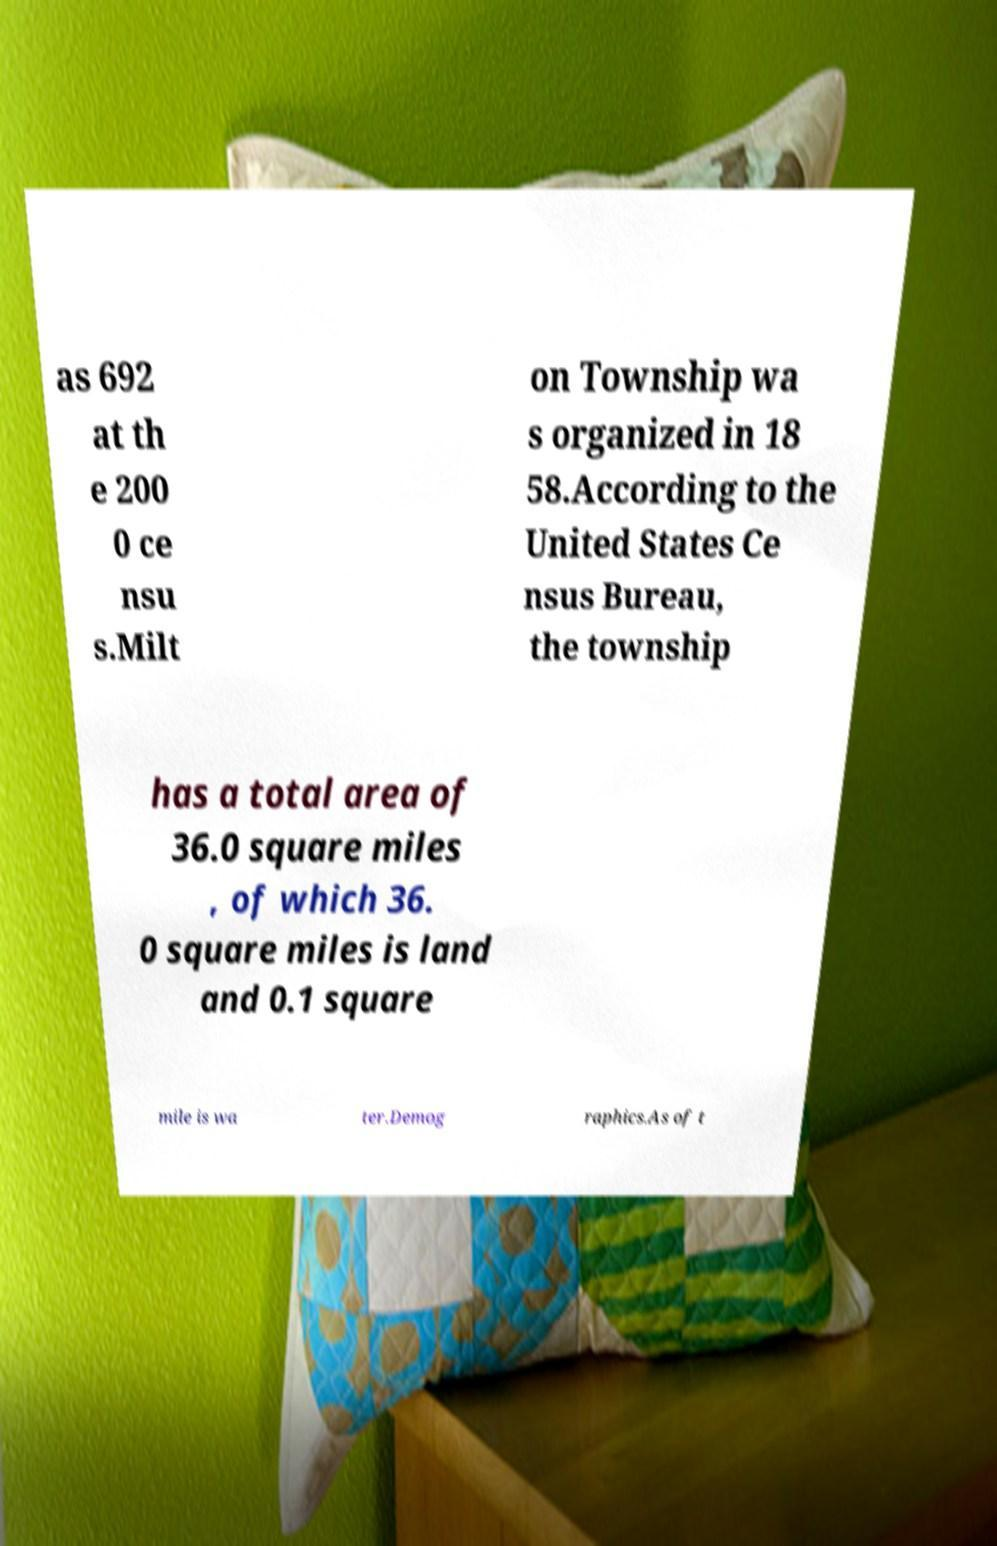What messages or text are displayed in this image? I need them in a readable, typed format. as 692 at th e 200 0 ce nsu s.Milt on Township wa s organized in 18 58.According to the United States Ce nsus Bureau, the township has a total area of 36.0 square miles , of which 36. 0 square miles is land and 0.1 square mile is wa ter.Demog raphics.As of t 